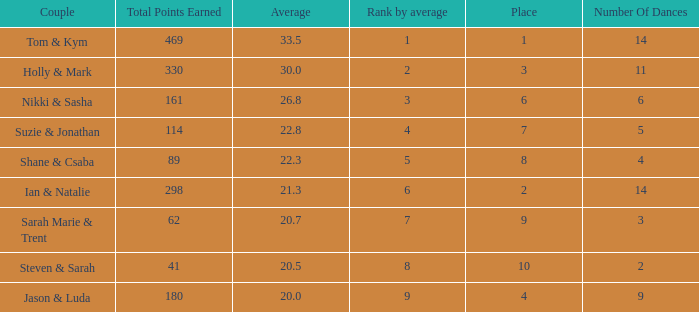What is the name of the couple if the total points earned is 161? Nikki & Sasha. 